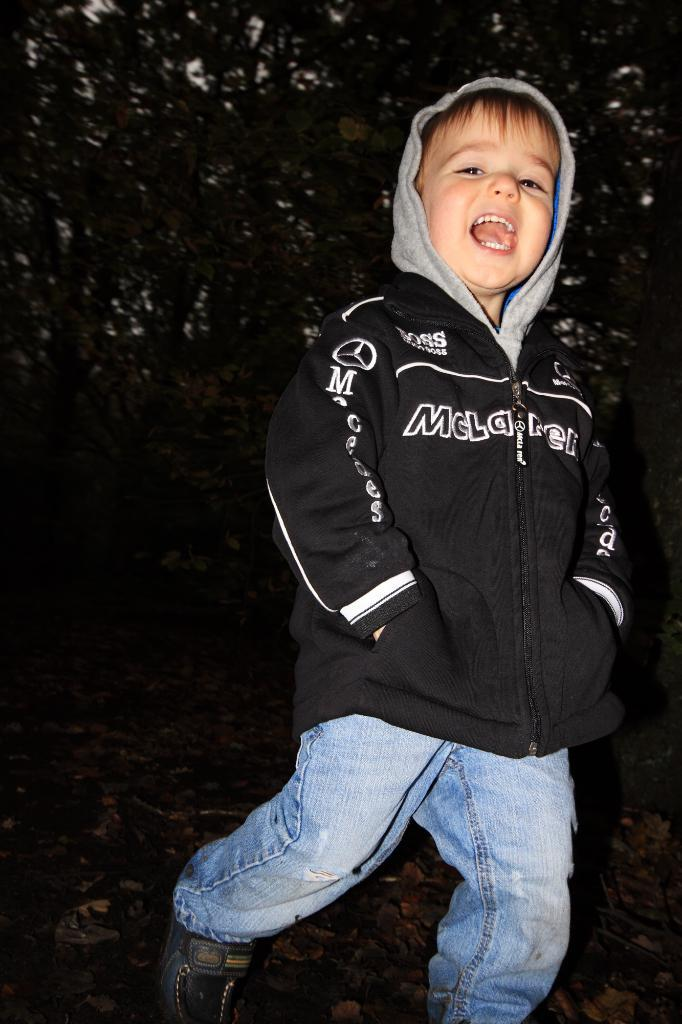What is the main subject in the foreground of the image? There is a boy in the foreground of the image. What is the boy doing in the image? The boy is screaming. What can be seen in the background of the image? There are trees in the background of the image. What is the boy's annual income in the image? There is no information about the boy's income in the image. What is the boy's tendency to scream in the image? The image only shows the boy screaming once, so it is not possible to determine a tendency from this single instance. 